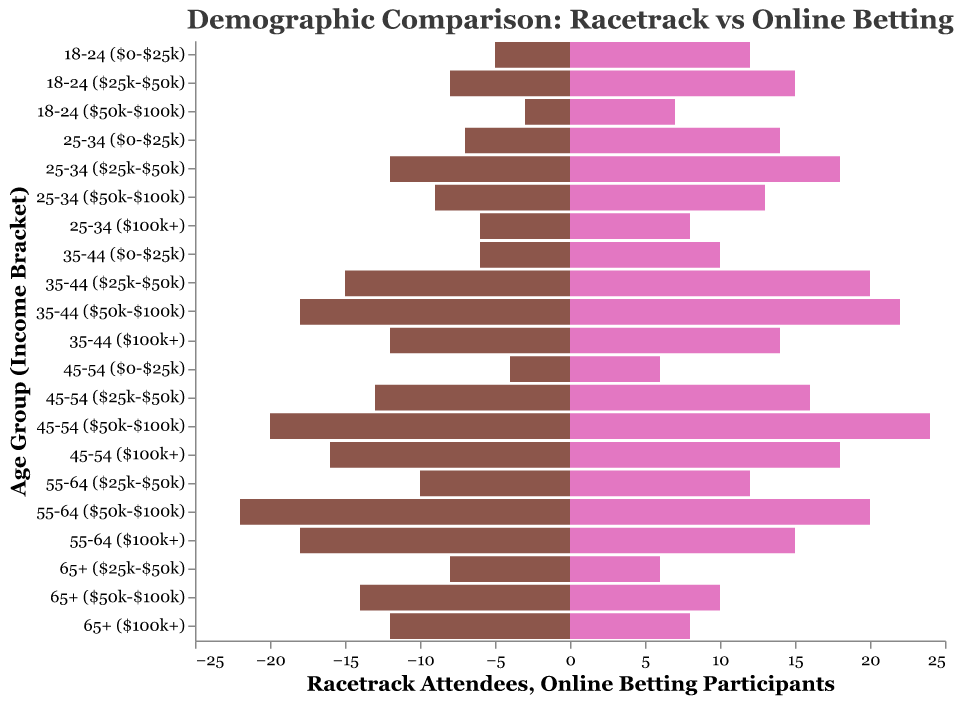What is the title of the figure? The title is found at the top of the figure and describes the main subject of the visualization.
Answer: Demographic Comparison: Racetrack vs Online Betting Which age and income group has the highest number of racetrack attendees? Look for the longest bar on the left side (Racetrack Attendees) and identify the corresponding age and income group on the y-axis.
Answer: 55-64 ($50k-$100k) What is the difference in the number of racetrack attendees and online betting participants for the age group 25-34 with an income of $25k-$50k? For the specified age and income group, subtract the number of racetrack attendees from online betting participants: 18 (Online Betting) - 12 (Racetrack) = 6.
Answer: 6 Which age group with an income of $100k+ has fewer online betting participants than racetrack attendees? Compare the lengths of the bars on the left and right sides for each age group with $100k+ income. See which bar on the left is longer than the one on the right.
Answer: 55-64 ($100k+) How does the number of online betting participants in the 18-24 age group with an income of $0-$25k compare to those with $50k-$100k? Compare the lengths of the bars on the right for the specified age and income groups: The 18-24 ($0-$25k) bar is longer than the 18-24 ($50k-$100k) bar.
Answer: More in $0-$25k For the 35-44 age group, which income bracket has the most significant difference between racetrack attendees and online betting participants? Calculate the differences between the bar lengths on the left and right for each income bracket within the 35-44 age group, and identify the largest difference.
Answer: $50k-$100k Which income bracket for the 45-54 age group has equal numbers of racetrack attendees and online betting participants? Look at the bars for the 45-54 age group and compare the lengths between racetrack attendees on the left and online betting participants on the right. Identify equal lengths.
Answer: None Among participants aged 65+ with $25k-$50k income, which group (racetrack attendees or online betting participants) is more prevalent? Compare the lengths of the bars for the age group 65+ ($25k-$50k) and see which is longer: The bar on the left or right.
Answer: Racetrack attendees What is the total number of racetrack attendees for individuals with an income of $50k-$100k across all age groups? Sum the racetrack attendees numbers for $50k-$100k income across all age groups: 3 + 9 + 18 + 20 + 22 + 14 = 86.
Answer: 86 